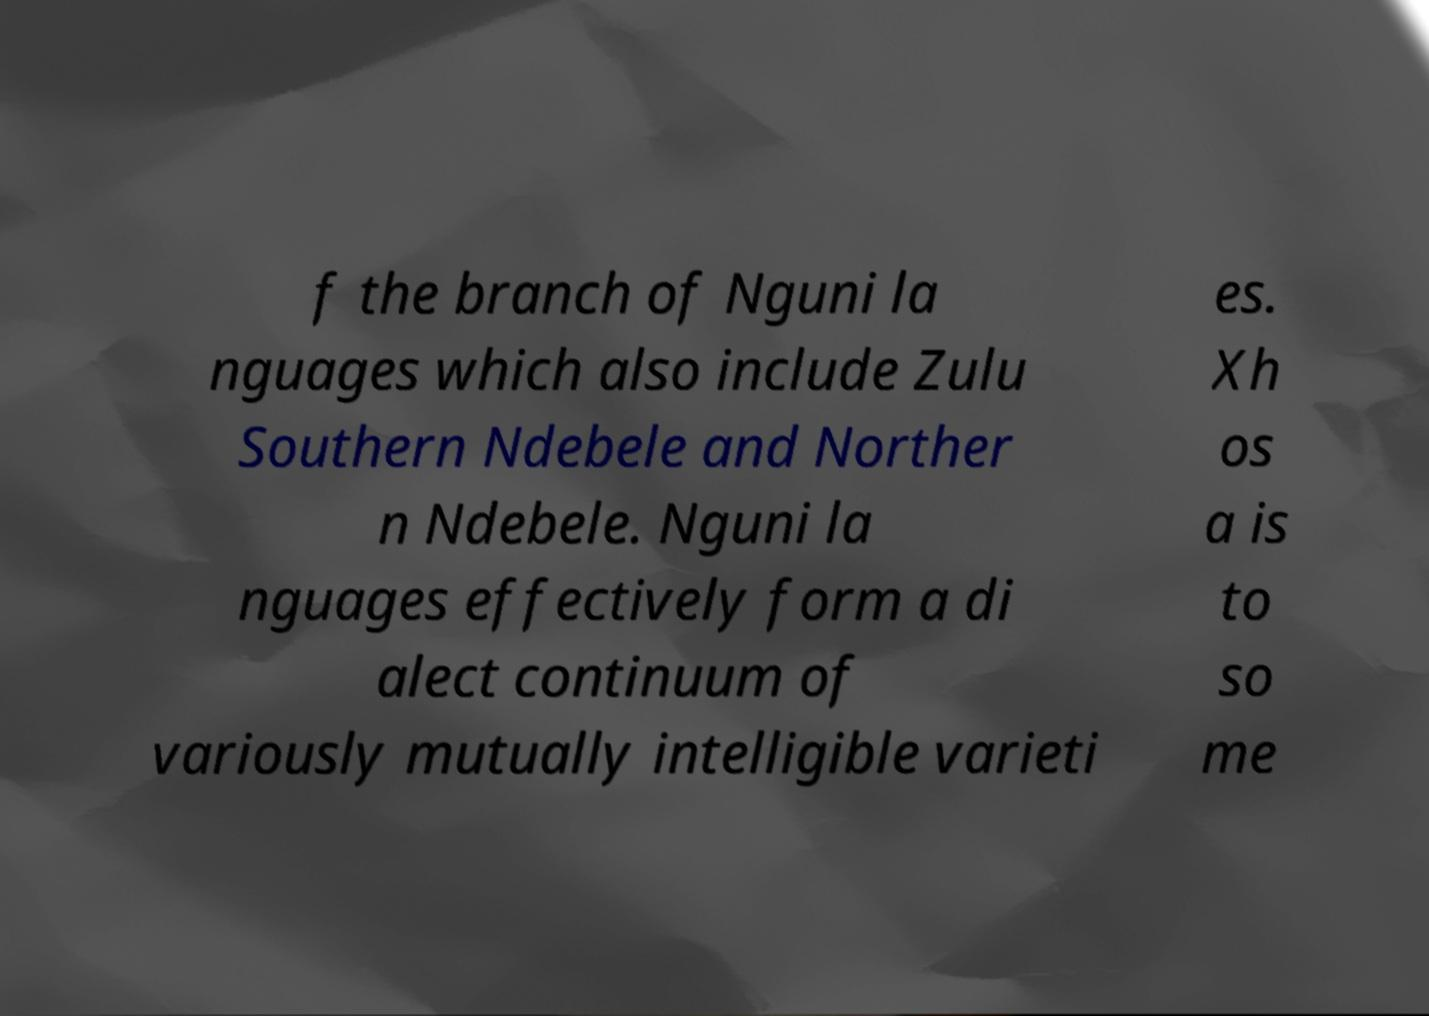Can you read and provide the text displayed in the image?This photo seems to have some interesting text. Can you extract and type it out for me? f the branch of Nguni la nguages which also include Zulu Southern Ndebele and Norther n Ndebele. Nguni la nguages effectively form a di alect continuum of variously mutually intelligible varieti es. Xh os a is to so me 